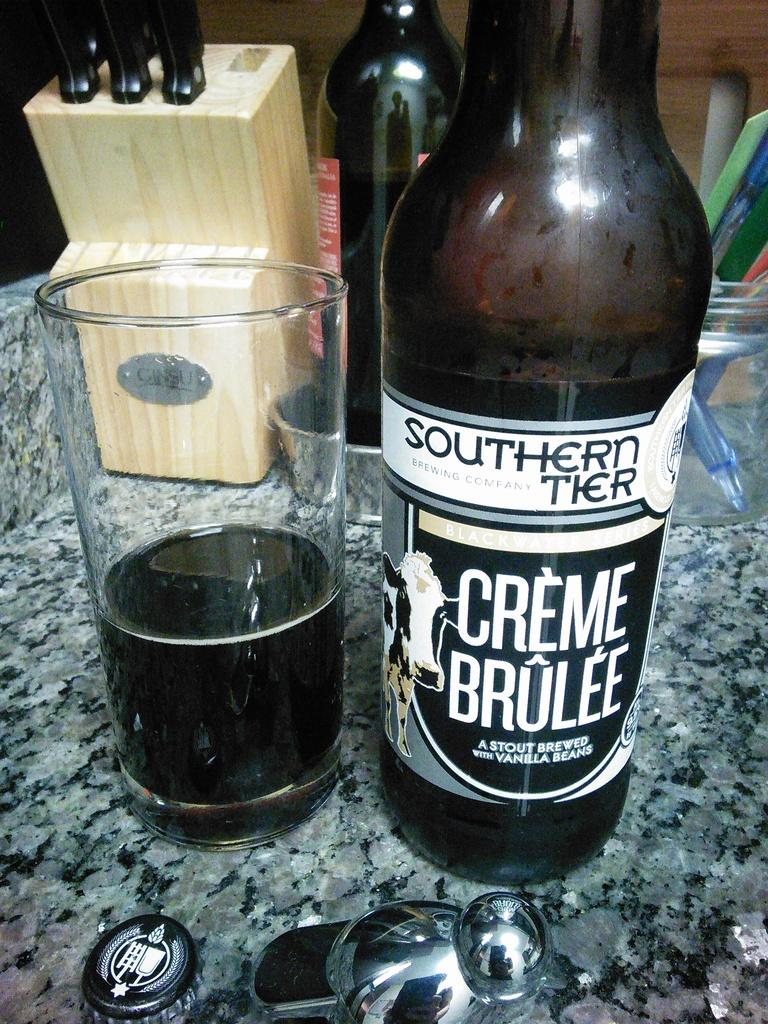<image>
Share a concise interpretation of the image provided. Bottle of Creme Brulee next to a cup of beer. 